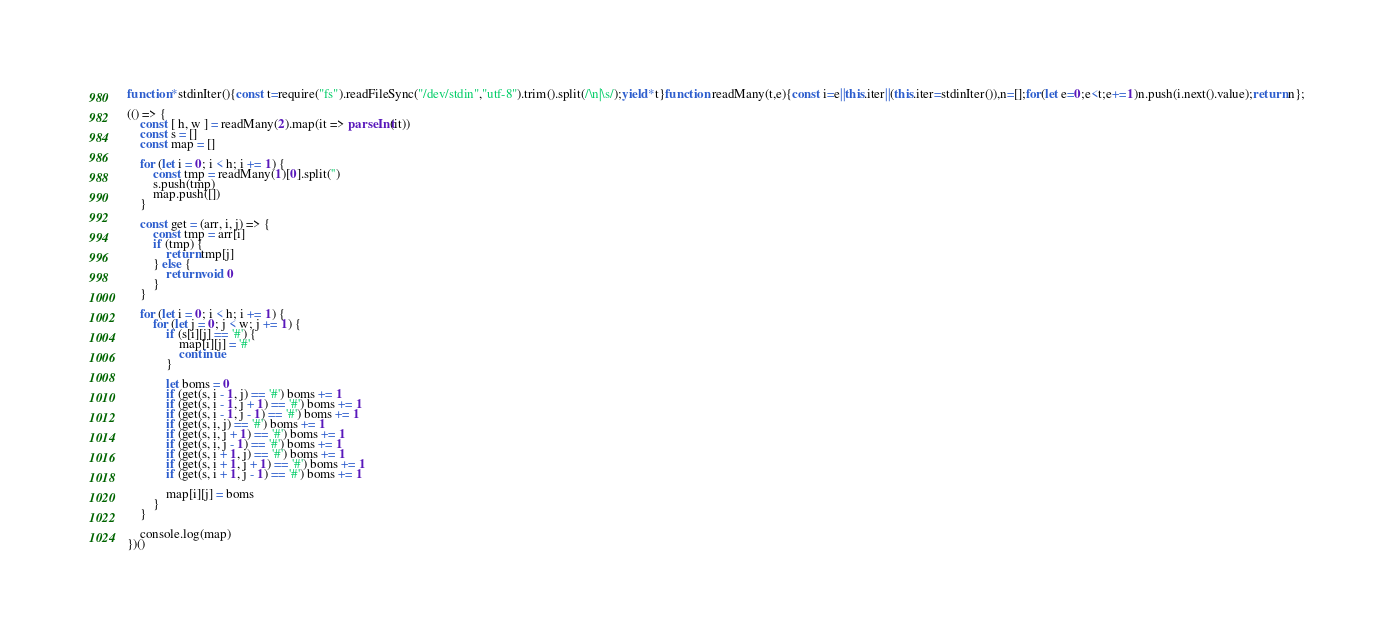Convert code to text. <code><loc_0><loc_0><loc_500><loc_500><_JavaScript_>function*stdinIter(){const t=require("fs").readFileSync("/dev/stdin","utf-8").trim().split(/\n|\s/);yield*t}function readMany(t,e){const i=e||this.iter||(this.iter=stdinIter()),n=[];for(let e=0;e<t;e+=1)n.push(i.next().value);return n};

(() => {
    const [ h, w ] = readMany(2).map(it => parseInt(it))
    const s = []
    const map = []

    for (let i = 0; i < h; i += 1) {
        const tmp = readMany(1)[0].split('')
        s.push(tmp)
        map.push([])
    }

    const get = (arr, i, j) => {
        const tmp = arr[i]
        if (tmp) {
            return tmp[j]
        } else {
            return void 0
        }
    }

    for (let i = 0; i < h; i += 1) {
        for (let j = 0; j < w; j += 1) {
            if (s[i][j] == '#') {
                map[i][j] = '#'
                continue
            }

            let boms = 0
            if (get(s, i - 1, j) == '#') boms += 1
            if (get(s, i - 1, j + 1) == '#') boms += 1
            if (get(s, i - 1, j - 1) == '#') boms += 1
            if (get(s, i, j) == '#') boms += 1
            if (get(s, i, j + 1) == '#') boms += 1
            if (get(s, i, j - 1) == '#') boms += 1
            if (get(s, i + 1, j) == '#') boms += 1
            if (get(s, i + 1, j + 1) == '#') boms += 1
            if (get(s, i + 1, j - 1) == '#') boms += 1

            map[i][j] = boms
        }
    }

    console.log(map)
})()
</code> 